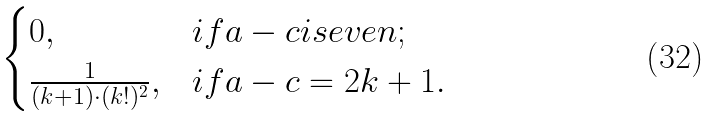Convert formula to latex. <formula><loc_0><loc_0><loc_500><loc_500>\begin{cases} 0 , & i f a - c i s e v e n ; \\ \frac { 1 } { ( k + 1 ) \cdot ( k ! ) ^ { 2 } } , & i f a - c = 2 k + 1 . \end{cases}</formula> 